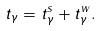<formula> <loc_0><loc_0><loc_500><loc_500>t _ { \gamma } = t ^ { s } _ { \gamma } + t ^ { w } _ { \gamma } .</formula> 